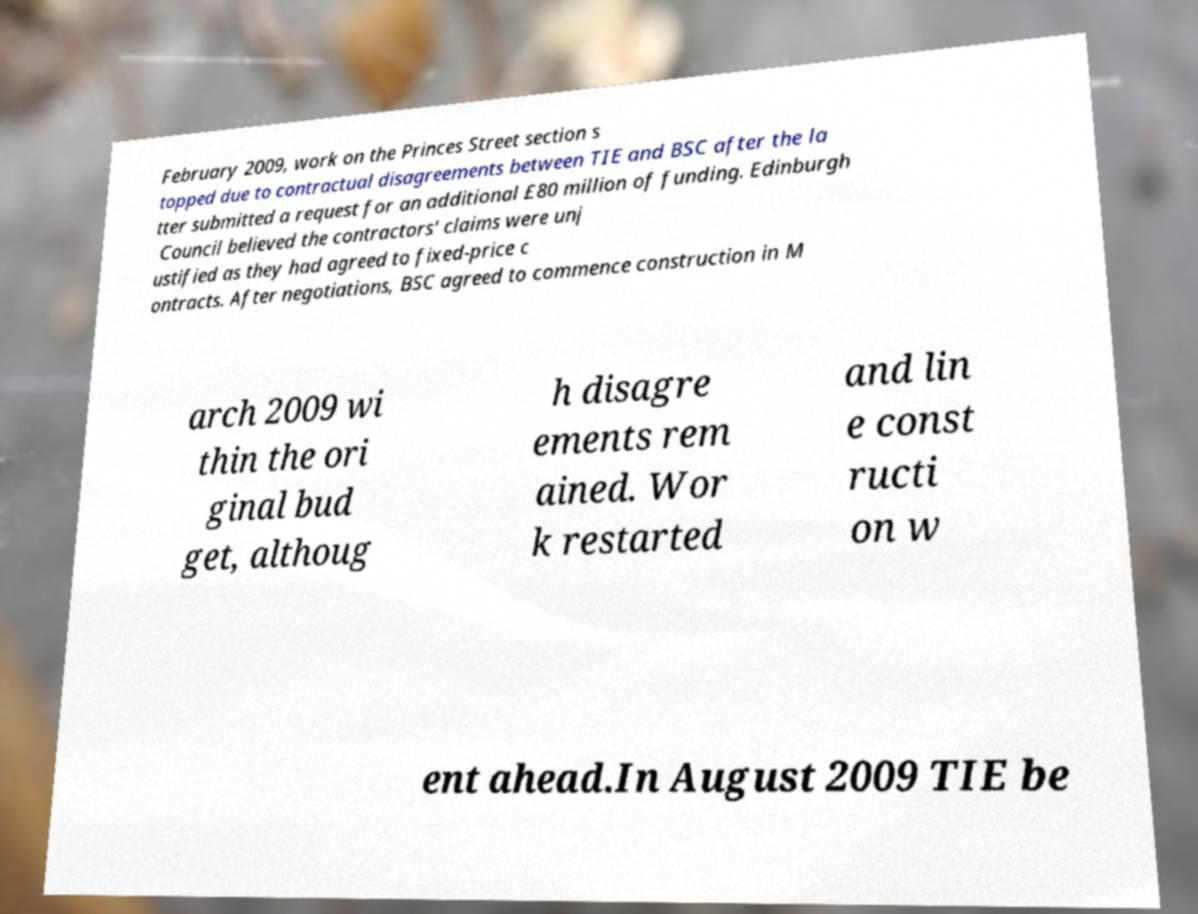I need the written content from this picture converted into text. Can you do that? February 2009, work on the Princes Street section s topped due to contractual disagreements between TIE and BSC after the la tter submitted a request for an additional £80 million of funding. Edinburgh Council believed the contractors' claims were unj ustified as they had agreed to fixed-price c ontracts. After negotiations, BSC agreed to commence construction in M arch 2009 wi thin the ori ginal bud get, althoug h disagre ements rem ained. Wor k restarted and lin e const ructi on w ent ahead.In August 2009 TIE be 